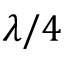<formula> <loc_0><loc_0><loc_500><loc_500>\lambda / 4</formula> 